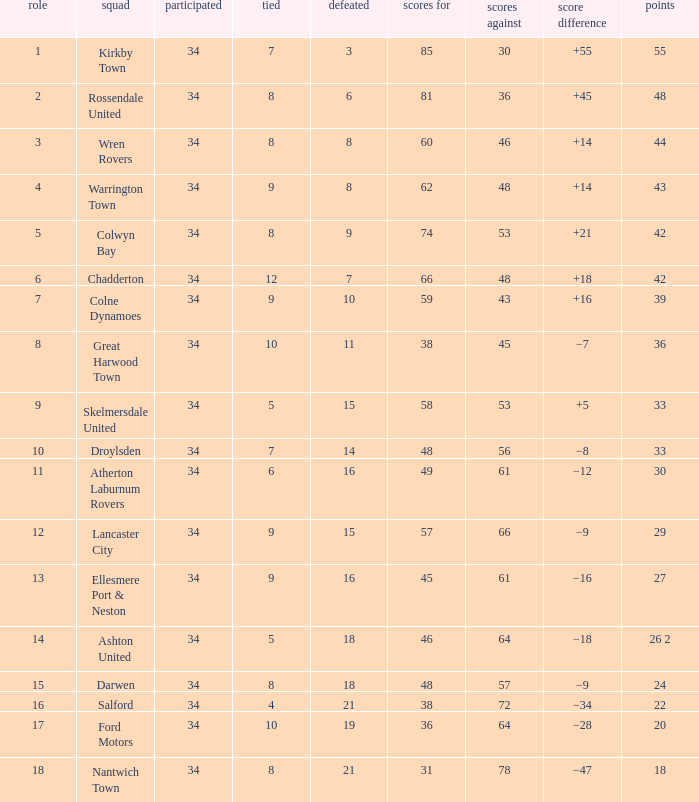What is the smallest number of goals against when 8 games were lost, and the goals for are 60? 46.0. 